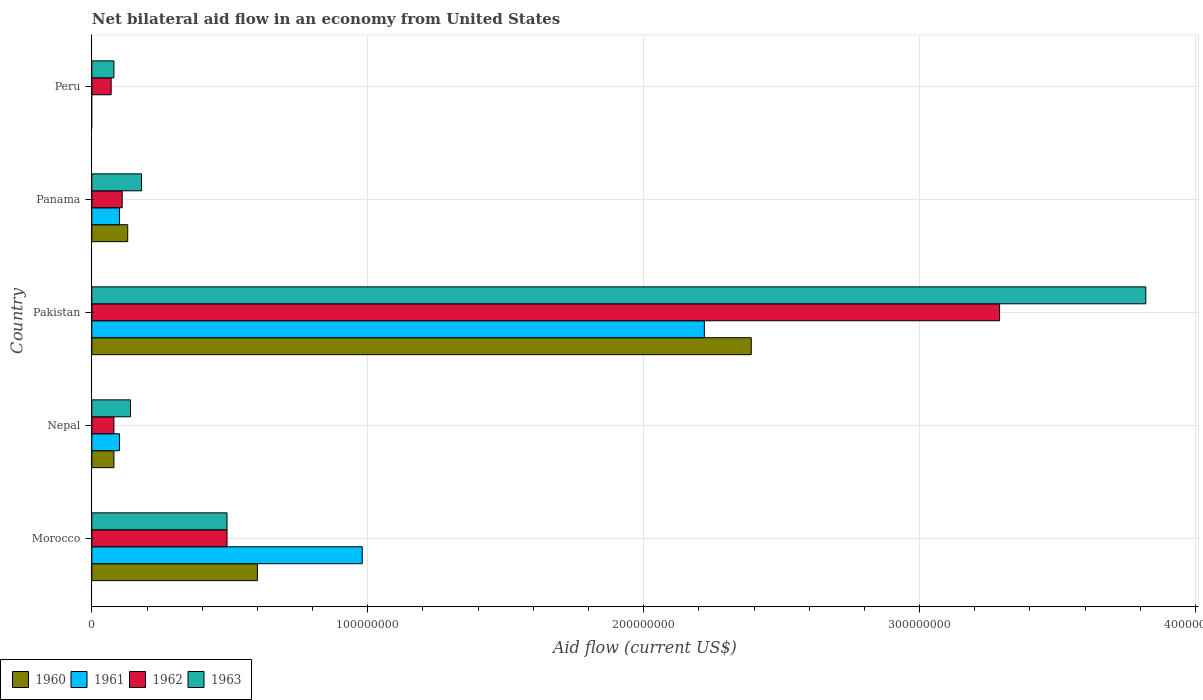How many different coloured bars are there?
Your answer should be very brief. 4. How many groups of bars are there?
Your answer should be very brief. 5. Are the number of bars per tick equal to the number of legend labels?
Offer a very short reply. No. How many bars are there on the 1st tick from the top?
Your answer should be compact. 2. What is the label of the 3rd group of bars from the top?
Provide a short and direct response. Pakistan. In how many cases, is the number of bars for a given country not equal to the number of legend labels?
Give a very brief answer. 1. What is the net bilateral aid flow in 1960 in Panama?
Provide a succinct answer. 1.30e+07. Across all countries, what is the maximum net bilateral aid flow in 1963?
Your response must be concise. 3.82e+08. Across all countries, what is the minimum net bilateral aid flow in 1960?
Provide a short and direct response. 0. What is the total net bilateral aid flow in 1962 in the graph?
Keep it short and to the point. 4.04e+08. What is the difference between the net bilateral aid flow in 1962 in Morocco and that in Nepal?
Your answer should be compact. 4.10e+07. What is the difference between the net bilateral aid flow in 1963 in Morocco and the net bilateral aid flow in 1961 in Nepal?
Provide a short and direct response. 3.90e+07. What is the average net bilateral aid flow in 1962 per country?
Offer a very short reply. 8.08e+07. What is the difference between the net bilateral aid flow in 1963 and net bilateral aid flow in 1962 in Pakistan?
Give a very brief answer. 5.30e+07. What is the ratio of the net bilateral aid flow in 1960 in Nepal to that in Pakistan?
Offer a very short reply. 0.03. What is the difference between the highest and the second highest net bilateral aid flow in 1962?
Your response must be concise. 2.80e+08. What is the difference between the highest and the lowest net bilateral aid flow in 1963?
Provide a succinct answer. 3.74e+08. How many bars are there?
Ensure brevity in your answer.  18. Are the values on the major ticks of X-axis written in scientific E-notation?
Your response must be concise. No. Where does the legend appear in the graph?
Provide a succinct answer. Bottom left. What is the title of the graph?
Offer a very short reply. Net bilateral aid flow in an economy from United States. Does "2015" appear as one of the legend labels in the graph?
Offer a very short reply. No. What is the Aid flow (current US$) in 1960 in Morocco?
Ensure brevity in your answer.  6.00e+07. What is the Aid flow (current US$) in 1961 in Morocco?
Keep it short and to the point. 9.80e+07. What is the Aid flow (current US$) of 1962 in Morocco?
Make the answer very short. 4.90e+07. What is the Aid flow (current US$) in 1963 in Morocco?
Your response must be concise. 4.90e+07. What is the Aid flow (current US$) in 1960 in Nepal?
Keep it short and to the point. 8.00e+06. What is the Aid flow (current US$) in 1962 in Nepal?
Your answer should be compact. 8.00e+06. What is the Aid flow (current US$) of 1963 in Nepal?
Offer a terse response. 1.40e+07. What is the Aid flow (current US$) of 1960 in Pakistan?
Offer a terse response. 2.39e+08. What is the Aid flow (current US$) in 1961 in Pakistan?
Keep it short and to the point. 2.22e+08. What is the Aid flow (current US$) of 1962 in Pakistan?
Make the answer very short. 3.29e+08. What is the Aid flow (current US$) of 1963 in Pakistan?
Offer a terse response. 3.82e+08. What is the Aid flow (current US$) in 1960 in Panama?
Ensure brevity in your answer.  1.30e+07. What is the Aid flow (current US$) in 1961 in Panama?
Provide a short and direct response. 1.00e+07. What is the Aid flow (current US$) of 1962 in Panama?
Keep it short and to the point. 1.10e+07. What is the Aid flow (current US$) of 1963 in Panama?
Ensure brevity in your answer.  1.80e+07. What is the Aid flow (current US$) in 1960 in Peru?
Your response must be concise. 0. What is the Aid flow (current US$) of 1962 in Peru?
Provide a short and direct response. 7.00e+06. What is the Aid flow (current US$) in 1963 in Peru?
Keep it short and to the point. 8.00e+06. Across all countries, what is the maximum Aid flow (current US$) of 1960?
Provide a short and direct response. 2.39e+08. Across all countries, what is the maximum Aid flow (current US$) of 1961?
Keep it short and to the point. 2.22e+08. Across all countries, what is the maximum Aid flow (current US$) of 1962?
Make the answer very short. 3.29e+08. Across all countries, what is the maximum Aid flow (current US$) in 1963?
Make the answer very short. 3.82e+08. What is the total Aid flow (current US$) of 1960 in the graph?
Your response must be concise. 3.20e+08. What is the total Aid flow (current US$) of 1961 in the graph?
Give a very brief answer. 3.40e+08. What is the total Aid flow (current US$) of 1962 in the graph?
Provide a succinct answer. 4.04e+08. What is the total Aid flow (current US$) in 1963 in the graph?
Ensure brevity in your answer.  4.71e+08. What is the difference between the Aid flow (current US$) in 1960 in Morocco and that in Nepal?
Give a very brief answer. 5.20e+07. What is the difference between the Aid flow (current US$) of 1961 in Morocco and that in Nepal?
Give a very brief answer. 8.80e+07. What is the difference between the Aid flow (current US$) of 1962 in Morocco and that in Nepal?
Provide a succinct answer. 4.10e+07. What is the difference between the Aid flow (current US$) in 1963 in Morocco and that in Nepal?
Your answer should be compact. 3.50e+07. What is the difference between the Aid flow (current US$) in 1960 in Morocco and that in Pakistan?
Offer a very short reply. -1.79e+08. What is the difference between the Aid flow (current US$) of 1961 in Morocco and that in Pakistan?
Provide a short and direct response. -1.24e+08. What is the difference between the Aid flow (current US$) of 1962 in Morocco and that in Pakistan?
Provide a succinct answer. -2.80e+08. What is the difference between the Aid flow (current US$) in 1963 in Morocco and that in Pakistan?
Keep it short and to the point. -3.33e+08. What is the difference between the Aid flow (current US$) in 1960 in Morocco and that in Panama?
Offer a very short reply. 4.70e+07. What is the difference between the Aid flow (current US$) in 1961 in Morocco and that in Panama?
Make the answer very short. 8.80e+07. What is the difference between the Aid flow (current US$) in 1962 in Morocco and that in Panama?
Offer a very short reply. 3.80e+07. What is the difference between the Aid flow (current US$) in 1963 in Morocco and that in Panama?
Give a very brief answer. 3.10e+07. What is the difference between the Aid flow (current US$) in 1962 in Morocco and that in Peru?
Give a very brief answer. 4.20e+07. What is the difference between the Aid flow (current US$) of 1963 in Morocco and that in Peru?
Your answer should be compact. 4.10e+07. What is the difference between the Aid flow (current US$) in 1960 in Nepal and that in Pakistan?
Provide a succinct answer. -2.31e+08. What is the difference between the Aid flow (current US$) in 1961 in Nepal and that in Pakistan?
Keep it short and to the point. -2.12e+08. What is the difference between the Aid flow (current US$) of 1962 in Nepal and that in Pakistan?
Your answer should be compact. -3.21e+08. What is the difference between the Aid flow (current US$) in 1963 in Nepal and that in Pakistan?
Make the answer very short. -3.68e+08. What is the difference between the Aid flow (current US$) of 1960 in Nepal and that in Panama?
Provide a short and direct response. -5.00e+06. What is the difference between the Aid flow (current US$) of 1962 in Nepal and that in Peru?
Your answer should be very brief. 1.00e+06. What is the difference between the Aid flow (current US$) of 1960 in Pakistan and that in Panama?
Provide a succinct answer. 2.26e+08. What is the difference between the Aid flow (current US$) of 1961 in Pakistan and that in Panama?
Offer a terse response. 2.12e+08. What is the difference between the Aid flow (current US$) in 1962 in Pakistan and that in Panama?
Your response must be concise. 3.18e+08. What is the difference between the Aid flow (current US$) of 1963 in Pakistan and that in Panama?
Your answer should be compact. 3.64e+08. What is the difference between the Aid flow (current US$) of 1962 in Pakistan and that in Peru?
Ensure brevity in your answer.  3.22e+08. What is the difference between the Aid flow (current US$) in 1963 in Pakistan and that in Peru?
Offer a very short reply. 3.74e+08. What is the difference between the Aid flow (current US$) of 1963 in Panama and that in Peru?
Make the answer very short. 1.00e+07. What is the difference between the Aid flow (current US$) in 1960 in Morocco and the Aid flow (current US$) in 1961 in Nepal?
Offer a terse response. 5.00e+07. What is the difference between the Aid flow (current US$) of 1960 in Morocco and the Aid flow (current US$) of 1962 in Nepal?
Offer a terse response. 5.20e+07. What is the difference between the Aid flow (current US$) of 1960 in Morocco and the Aid flow (current US$) of 1963 in Nepal?
Your response must be concise. 4.60e+07. What is the difference between the Aid flow (current US$) of 1961 in Morocco and the Aid flow (current US$) of 1962 in Nepal?
Offer a very short reply. 9.00e+07. What is the difference between the Aid flow (current US$) in 1961 in Morocco and the Aid flow (current US$) in 1963 in Nepal?
Your response must be concise. 8.40e+07. What is the difference between the Aid flow (current US$) in 1962 in Morocco and the Aid flow (current US$) in 1963 in Nepal?
Your response must be concise. 3.50e+07. What is the difference between the Aid flow (current US$) of 1960 in Morocco and the Aid flow (current US$) of 1961 in Pakistan?
Give a very brief answer. -1.62e+08. What is the difference between the Aid flow (current US$) of 1960 in Morocco and the Aid flow (current US$) of 1962 in Pakistan?
Keep it short and to the point. -2.69e+08. What is the difference between the Aid flow (current US$) in 1960 in Morocco and the Aid flow (current US$) in 1963 in Pakistan?
Provide a short and direct response. -3.22e+08. What is the difference between the Aid flow (current US$) in 1961 in Morocco and the Aid flow (current US$) in 1962 in Pakistan?
Make the answer very short. -2.31e+08. What is the difference between the Aid flow (current US$) in 1961 in Morocco and the Aid flow (current US$) in 1963 in Pakistan?
Your response must be concise. -2.84e+08. What is the difference between the Aid flow (current US$) of 1962 in Morocco and the Aid flow (current US$) of 1963 in Pakistan?
Offer a very short reply. -3.33e+08. What is the difference between the Aid flow (current US$) of 1960 in Morocco and the Aid flow (current US$) of 1962 in Panama?
Give a very brief answer. 4.90e+07. What is the difference between the Aid flow (current US$) in 1960 in Morocco and the Aid flow (current US$) in 1963 in Panama?
Ensure brevity in your answer.  4.20e+07. What is the difference between the Aid flow (current US$) of 1961 in Morocco and the Aid flow (current US$) of 1962 in Panama?
Your answer should be very brief. 8.70e+07. What is the difference between the Aid flow (current US$) in 1961 in Morocco and the Aid flow (current US$) in 1963 in Panama?
Your answer should be compact. 8.00e+07. What is the difference between the Aid flow (current US$) of 1962 in Morocco and the Aid flow (current US$) of 1963 in Panama?
Your response must be concise. 3.10e+07. What is the difference between the Aid flow (current US$) in 1960 in Morocco and the Aid flow (current US$) in 1962 in Peru?
Your response must be concise. 5.30e+07. What is the difference between the Aid flow (current US$) in 1960 in Morocco and the Aid flow (current US$) in 1963 in Peru?
Your response must be concise. 5.20e+07. What is the difference between the Aid flow (current US$) in 1961 in Morocco and the Aid flow (current US$) in 1962 in Peru?
Give a very brief answer. 9.10e+07. What is the difference between the Aid flow (current US$) of 1961 in Morocco and the Aid flow (current US$) of 1963 in Peru?
Your response must be concise. 9.00e+07. What is the difference between the Aid flow (current US$) in 1962 in Morocco and the Aid flow (current US$) in 1963 in Peru?
Offer a terse response. 4.10e+07. What is the difference between the Aid flow (current US$) in 1960 in Nepal and the Aid flow (current US$) in 1961 in Pakistan?
Give a very brief answer. -2.14e+08. What is the difference between the Aid flow (current US$) of 1960 in Nepal and the Aid flow (current US$) of 1962 in Pakistan?
Provide a short and direct response. -3.21e+08. What is the difference between the Aid flow (current US$) in 1960 in Nepal and the Aid flow (current US$) in 1963 in Pakistan?
Give a very brief answer. -3.74e+08. What is the difference between the Aid flow (current US$) of 1961 in Nepal and the Aid flow (current US$) of 1962 in Pakistan?
Give a very brief answer. -3.19e+08. What is the difference between the Aid flow (current US$) in 1961 in Nepal and the Aid flow (current US$) in 1963 in Pakistan?
Offer a very short reply. -3.72e+08. What is the difference between the Aid flow (current US$) in 1962 in Nepal and the Aid flow (current US$) in 1963 in Pakistan?
Your response must be concise. -3.74e+08. What is the difference between the Aid flow (current US$) of 1960 in Nepal and the Aid flow (current US$) of 1962 in Panama?
Offer a very short reply. -3.00e+06. What is the difference between the Aid flow (current US$) in 1960 in Nepal and the Aid flow (current US$) in 1963 in Panama?
Keep it short and to the point. -1.00e+07. What is the difference between the Aid flow (current US$) of 1961 in Nepal and the Aid flow (current US$) of 1963 in Panama?
Offer a very short reply. -8.00e+06. What is the difference between the Aid flow (current US$) in 1962 in Nepal and the Aid flow (current US$) in 1963 in Panama?
Give a very brief answer. -1.00e+07. What is the difference between the Aid flow (current US$) of 1960 in Nepal and the Aid flow (current US$) of 1962 in Peru?
Your answer should be compact. 1.00e+06. What is the difference between the Aid flow (current US$) in 1960 in Nepal and the Aid flow (current US$) in 1963 in Peru?
Your answer should be compact. 0. What is the difference between the Aid flow (current US$) in 1961 in Nepal and the Aid flow (current US$) in 1963 in Peru?
Ensure brevity in your answer.  2.00e+06. What is the difference between the Aid flow (current US$) of 1960 in Pakistan and the Aid flow (current US$) of 1961 in Panama?
Your answer should be compact. 2.29e+08. What is the difference between the Aid flow (current US$) of 1960 in Pakistan and the Aid flow (current US$) of 1962 in Panama?
Provide a short and direct response. 2.28e+08. What is the difference between the Aid flow (current US$) of 1960 in Pakistan and the Aid flow (current US$) of 1963 in Panama?
Your answer should be very brief. 2.21e+08. What is the difference between the Aid flow (current US$) of 1961 in Pakistan and the Aid flow (current US$) of 1962 in Panama?
Offer a terse response. 2.11e+08. What is the difference between the Aid flow (current US$) in 1961 in Pakistan and the Aid flow (current US$) in 1963 in Panama?
Your response must be concise. 2.04e+08. What is the difference between the Aid flow (current US$) of 1962 in Pakistan and the Aid flow (current US$) of 1963 in Panama?
Your answer should be compact. 3.11e+08. What is the difference between the Aid flow (current US$) in 1960 in Pakistan and the Aid flow (current US$) in 1962 in Peru?
Keep it short and to the point. 2.32e+08. What is the difference between the Aid flow (current US$) in 1960 in Pakistan and the Aid flow (current US$) in 1963 in Peru?
Your answer should be compact. 2.31e+08. What is the difference between the Aid flow (current US$) in 1961 in Pakistan and the Aid flow (current US$) in 1962 in Peru?
Give a very brief answer. 2.15e+08. What is the difference between the Aid flow (current US$) of 1961 in Pakistan and the Aid flow (current US$) of 1963 in Peru?
Your answer should be very brief. 2.14e+08. What is the difference between the Aid flow (current US$) in 1962 in Pakistan and the Aid flow (current US$) in 1963 in Peru?
Your response must be concise. 3.21e+08. What is the difference between the Aid flow (current US$) in 1961 in Panama and the Aid flow (current US$) in 1962 in Peru?
Offer a very short reply. 3.00e+06. What is the difference between the Aid flow (current US$) of 1961 in Panama and the Aid flow (current US$) of 1963 in Peru?
Offer a very short reply. 2.00e+06. What is the difference between the Aid flow (current US$) in 1962 in Panama and the Aid flow (current US$) in 1963 in Peru?
Offer a terse response. 3.00e+06. What is the average Aid flow (current US$) in 1960 per country?
Keep it short and to the point. 6.40e+07. What is the average Aid flow (current US$) of 1961 per country?
Provide a short and direct response. 6.80e+07. What is the average Aid flow (current US$) in 1962 per country?
Your answer should be compact. 8.08e+07. What is the average Aid flow (current US$) in 1963 per country?
Provide a short and direct response. 9.42e+07. What is the difference between the Aid flow (current US$) in 1960 and Aid flow (current US$) in 1961 in Morocco?
Give a very brief answer. -3.80e+07. What is the difference between the Aid flow (current US$) of 1960 and Aid flow (current US$) of 1962 in Morocco?
Ensure brevity in your answer.  1.10e+07. What is the difference between the Aid flow (current US$) in 1960 and Aid flow (current US$) in 1963 in Morocco?
Your response must be concise. 1.10e+07. What is the difference between the Aid flow (current US$) of 1961 and Aid flow (current US$) of 1962 in Morocco?
Your response must be concise. 4.90e+07. What is the difference between the Aid flow (current US$) in 1961 and Aid flow (current US$) in 1963 in Morocco?
Your response must be concise. 4.90e+07. What is the difference between the Aid flow (current US$) of 1960 and Aid flow (current US$) of 1961 in Nepal?
Provide a succinct answer. -2.00e+06. What is the difference between the Aid flow (current US$) of 1960 and Aid flow (current US$) of 1963 in Nepal?
Give a very brief answer. -6.00e+06. What is the difference between the Aid flow (current US$) of 1961 and Aid flow (current US$) of 1962 in Nepal?
Keep it short and to the point. 2.00e+06. What is the difference between the Aid flow (current US$) in 1962 and Aid flow (current US$) in 1963 in Nepal?
Offer a very short reply. -6.00e+06. What is the difference between the Aid flow (current US$) of 1960 and Aid flow (current US$) of 1961 in Pakistan?
Make the answer very short. 1.70e+07. What is the difference between the Aid flow (current US$) of 1960 and Aid flow (current US$) of 1962 in Pakistan?
Make the answer very short. -9.00e+07. What is the difference between the Aid flow (current US$) in 1960 and Aid flow (current US$) in 1963 in Pakistan?
Your answer should be very brief. -1.43e+08. What is the difference between the Aid flow (current US$) of 1961 and Aid flow (current US$) of 1962 in Pakistan?
Your response must be concise. -1.07e+08. What is the difference between the Aid flow (current US$) of 1961 and Aid flow (current US$) of 1963 in Pakistan?
Your response must be concise. -1.60e+08. What is the difference between the Aid flow (current US$) of 1962 and Aid flow (current US$) of 1963 in Pakistan?
Offer a very short reply. -5.30e+07. What is the difference between the Aid flow (current US$) in 1960 and Aid flow (current US$) in 1961 in Panama?
Offer a terse response. 3.00e+06. What is the difference between the Aid flow (current US$) in 1960 and Aid flow (current US$) in 1962 in Panama?
Provide a succinct answer. 2.00e+06. What is the difference between the Aid flow (current US$) in 1960 and Aid flow (current US$) in 1963 in Panama?
Provide a short and direct response. -5.00e+06. What is the difference between the Aid flow (current US$) of 1961 and Aid flow (current US$) of 1963 in Panama?
Offer a terse response. -8.00e+06. What is the difference between the Aid flow (current US$) in 1962 and Aid flow (current US$) in 1963 in Panama?
Offer a very short reply. -7.00e+06. What is the ratio of the Aid flow (current US$) in 1961 in Morocco to that in Nepal?
Your answer should be compact. 9.8. What is the ratio of the Aid flow (current US$) of 1962 in Morocco to that in Nepal?
Your response must be concise. 6.12. What is the ratio of the Aid flow (current US$) in 1963 in Morocco to that in Nepal?
Provide a short and direct response. 3.5. What is the ratio of the Aid flow (current US$) of 1960 in Morocco to that in Pakistan?
Make the answer very short. 0.25. What is the ratio of the Aid flow (current US$) in 1961 in Morocco to that in Pakistan?
Ensure brevity in your answer.  0.44. What is the ratio of the Aid flow (current US$) of 1962 in Morocco to that in Pakistan?
Your answer should be compact. 0.15. What is the ratio of the Aid flow (current US$) of 1963 in Morocco to that in Pakistan?
Offer a terse response. 0.13. What is the ratio of the Aid flow (current US$) of 1960 in Morocco to that in Panama?
Provide a short and direct response. 4.62. What is the ratio of the Aid flow (current US$) of 1962 in Morocco to that in Panama?
Offer a very short reply. 4.45. What is the ratio of the Aid flow (current US$) in 1963 in Morocco to that in Panama?
Ensure brevity in your answer.  2.72. What is the ratio of the Aid flow (current US$) of 1962 in Morocco to that in Peru?
Ensure brevity in your answer.  7. What is the ratio of the Aid flow (current US$) of 1963 in Morocco to that in Peru?
Make the answer very short. 6.12. What is the ratio of the Aid flow (current US$) in 1960 in Nepal to that in Pakistan?
Ensure brevity in your answer.  0.03. What is the ratio of the Aid flow (current US$) of 1961 in Nepal to that in Pakistan?
Provide a succinct answer. 0.04. What is the ratio of the Aid flow (current US$) of 1962 in Nepal to that in Pakistan?
Provide a succinct answer. 0.02. What is the ratio of the Aid flow (current US$) in 1963 in Nepal to that in Pakistan?
Provide a short and direct response. 0.04. What is the ratio of the Aid flow (current US$) in 1960 in Nepal to that in Panama?
Ensure brevity in your answer.  0.62. What is the ratio of the Aid flow (current US$) of 1961 in Nepal to that in Panama?
Your answer should be very brief. 1. What is the ratio of the Aid flow (current US$) of 1962 in Nepal to that in Panama?
Offer a very short reply. 0.73. What is the ratio of the Aid flow (current US$) in 1960 in Pakistan to that in Panama?
Keep it short and to the point. 18.38. What is the ratio of the Aid flow (current US$) in 1961 in Pakistan to that in Panama?
Ensure brevity in your answer.  22.2. What is the ratio of the Aid flow (current US$) of 1962 in Pakistan to that in Panama?
Offer a terse response. 29.91. What is the ratio of the Aid flow (current US$) of 1963 in Pakistan to that in Panama?
Your response must be concise. 21.22. What is the ratio of the Aid flow (current US$) in 1962 in Pakistan to that in Peru?
Ensure brevity in your answer.  47. What is the ratio of the Aid flow (current US$) in 1963 in Pakistan to that in Peru?
Give a very brief answer. 47.75. What is the ratio of the Aid flow (current US$) of 1962 in Panama to that in Peru?
Offer a very short reply. 1.57. What is the ratio of the Aid flow (current US$) of 1963 in Panama to that in Peru?
Provide a short and direct response. 2.25. What is the difference between the highest and the second highest Aid flow (current US$) of 1960?
Your answer should be very brief. 1.79e+08. What is the difference between the highest and the second highest Aid flow (current US$) in 1961?
Offer a very short reply. 1.24e+08. What is the difference between the highest and the second highest Aid flow (current US$) in 1962?
Keep it short and to the point. 2.80e+08. What is the difference between the highest and the second highest Aid flow (current US$) in 1963?
Keep it short and to the point. 3.33e+08. What is the difference between the highest and the lowest Aid flow (current US$) in 1960?
Ensure brevity in your answer.  2.39e+08. What is the difference between the highest and the lowest Aid flow (current US$) in 1961?
Offer a terse response. 2.22e+08. What is the difference between the highest and the lowest Aid flow (current US$) of 1962?
Keep it short and to the point. 3.22e+08. What is the difference between the highest and the lowest Aid flow (current US$) of 1963?
Your answer should be very brief. 3.74e+08. 